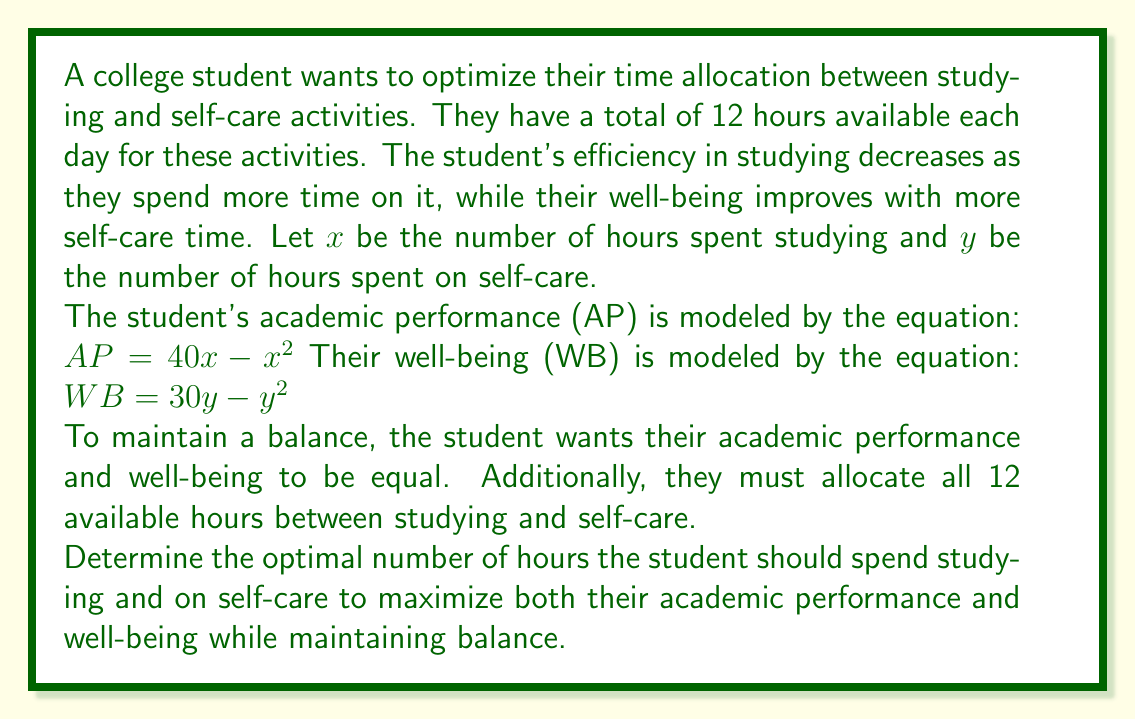Can you answer this question? Let's approach this problem step by step:

1) We have two constraints:
   a) $x + y = 12$ (total time constraint)
   b) $AP = WB$ (balance constraint)

2) Substituting the given equations into the balance constraint:
   $40x - x^2 = 30y - y^2$

3) From the total time constraint, we know that $y = 12 - x$. Let's substitute this into the balance equation:
   $40x - x^2 = 30(12 - x) - (12 - x)^2$

4) Expand the right side:
   $40x - x^2 = 360 - 30x - (144 - 24x + x^2)$

5) Simplify:
   $40x - x^2 = 360 - 30x - 144 + 24x - x^2$
   $40x - x^2 = 216 - 6x - x^2$

6) Cancel out $-x^2$ on both sides:
   $40x = 216 - 6x$

7) Combine like terms:
   $46x = 216$

8) Solve for $x$:
   $x = 216 / 46 = 4.7$ hours

9) To find $y$, use the total time constraint:
   $y = 12 - x = 12 - 4.7 = 7.3$ hours

10) Verify the balance:
    $AP = 40(4.7) - 4.7^2 = 188 - 22.09 = 165.91$
    $WB = 30(7.3) - 7.3^2 = 219 - 53.29 = 165.71$

    The slight difference is due to rounding.

Therefore, the optimal time allocation is approximately 4.7 hours for studying and 7.3 hours for self-care.
Answer: The student should spend approximately 4.7 hours studying and 7.3 hours on self-care activities. 